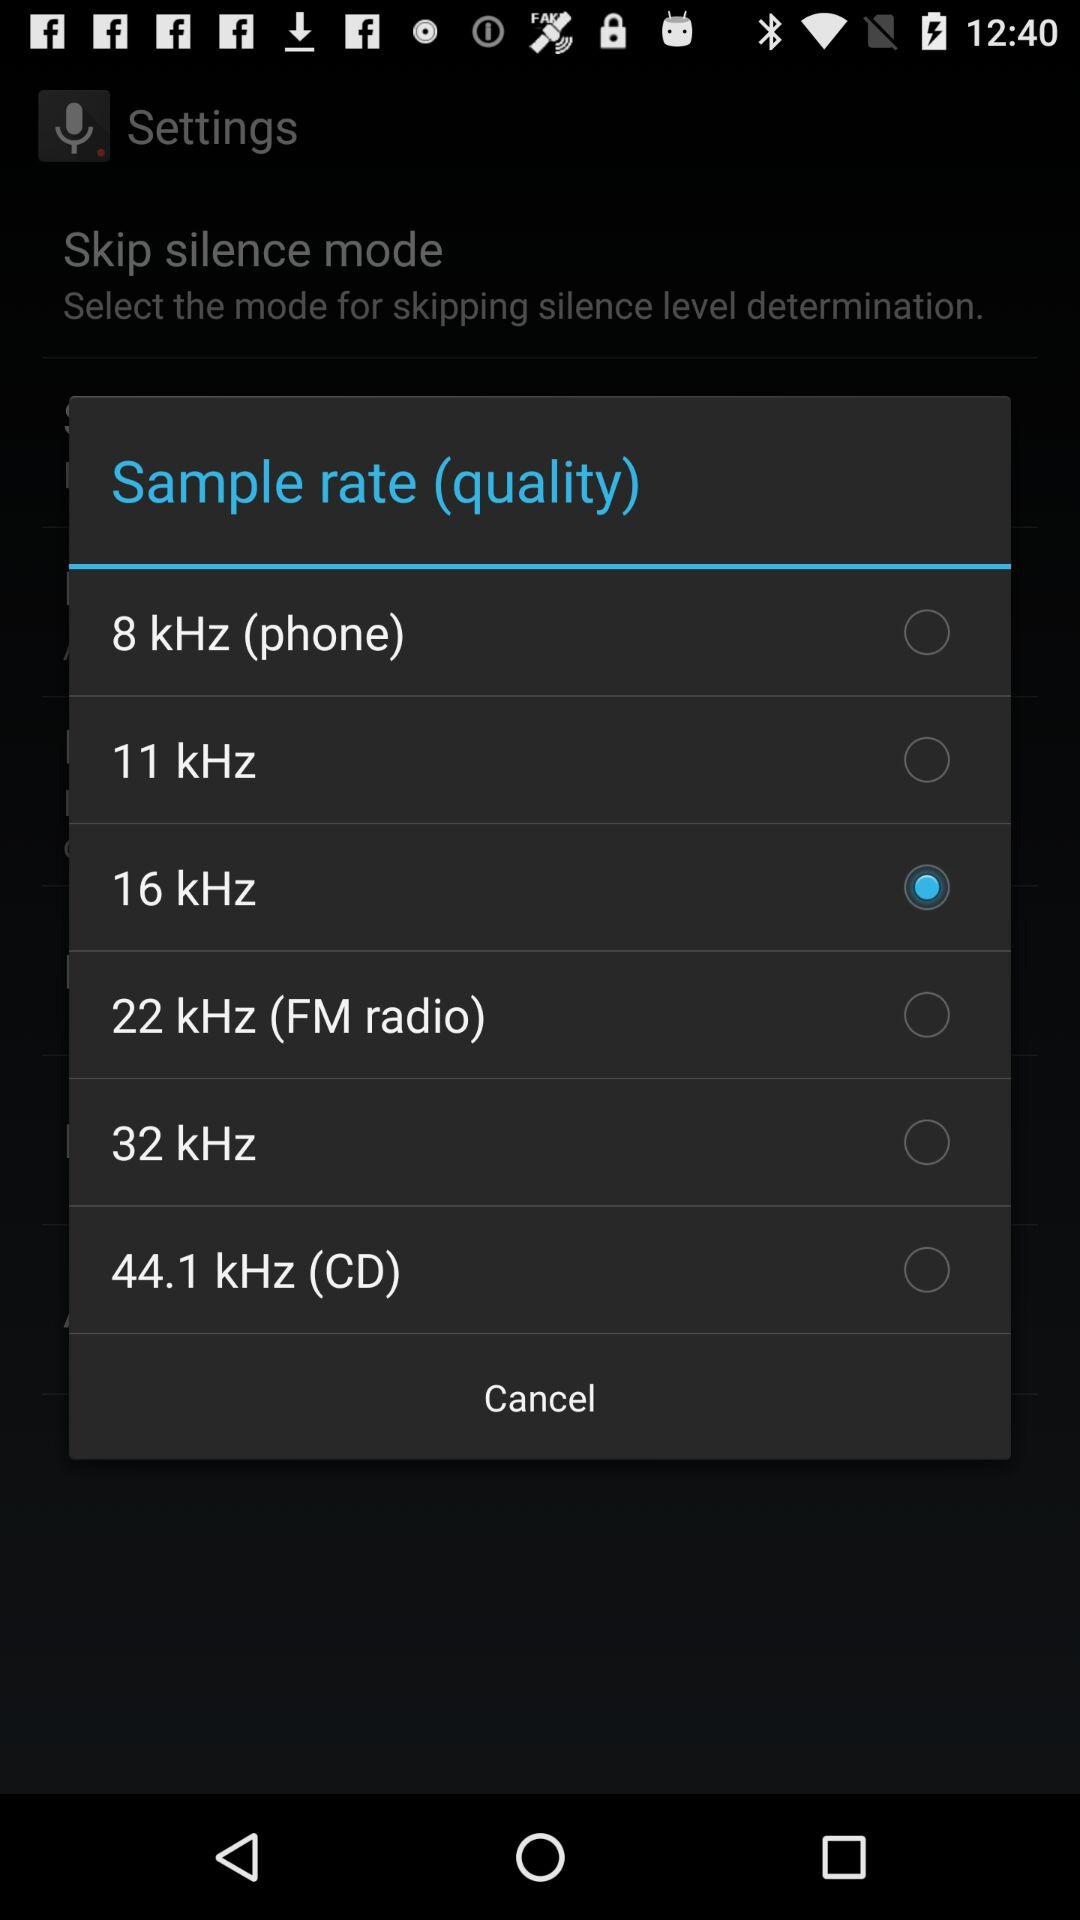Which sample rate is the highest?
Answer the question using a single word or phrase. 44.1 kHz 